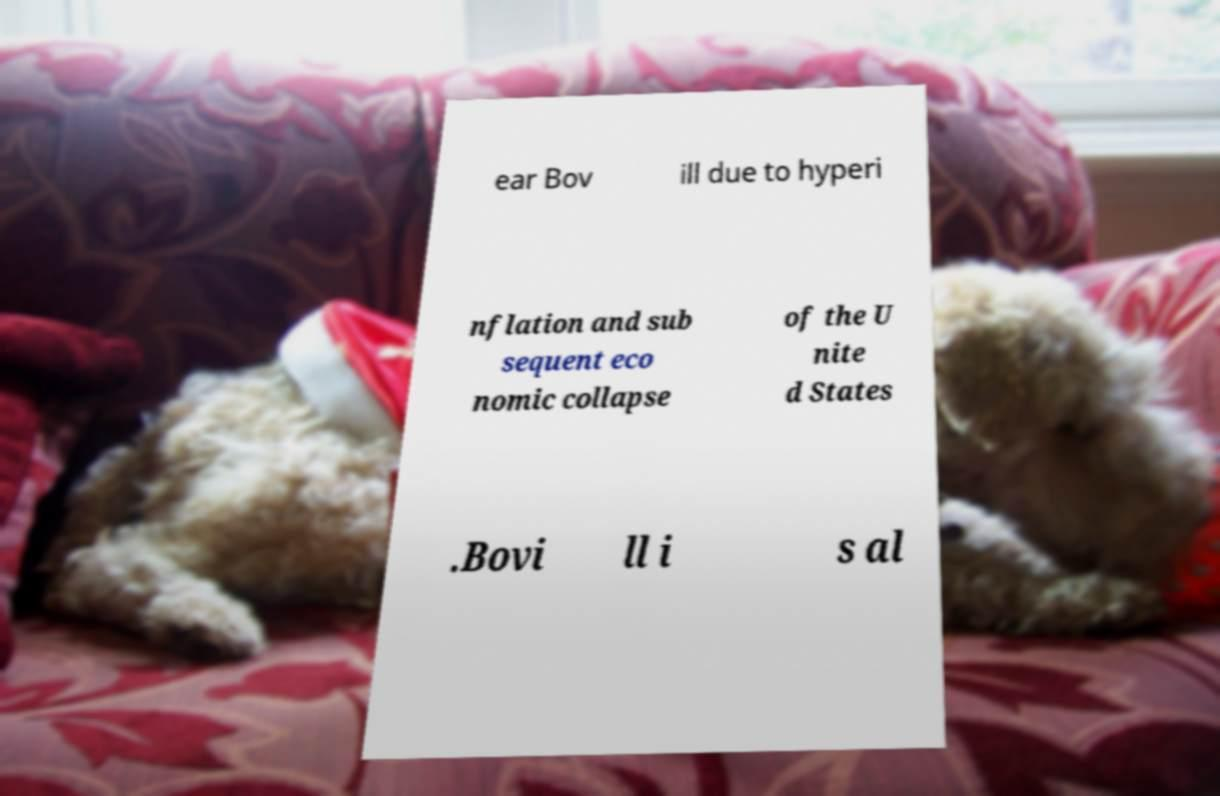What messages or text are displayed in this image? I need them in a readable, typed format. ear Bov ill due to hyperi nflation and sub sequent eco nomic collapse of the U nite d States .Bovi ll i s al 